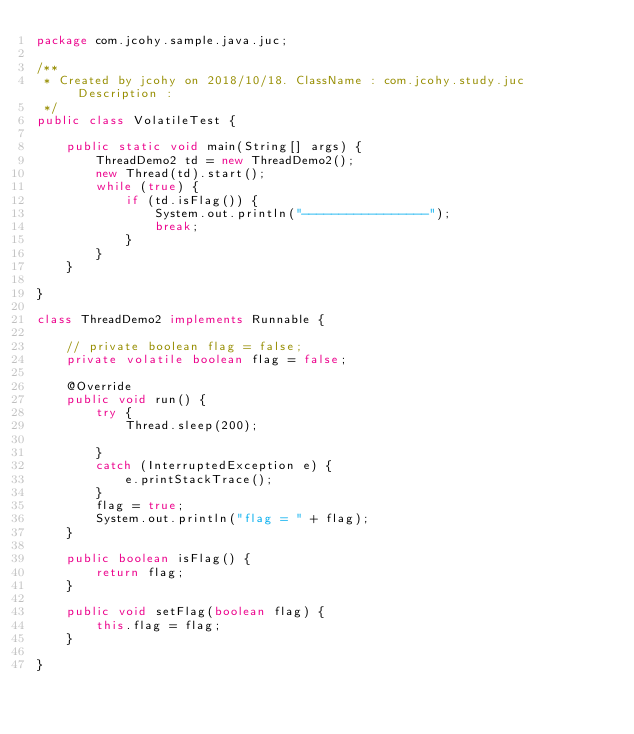<code> <loc_0><loc_0><loc_500><loc_500><_Java_>package com.jcohy.sample.java.juc;

/**
 * Created by jcohy on 2018/10/18. ClassName : com.jcohy.study.juc Description :
 */
public class VolatileTest {

	public static void main(String[] args) {
		ThreadDemo2 td = new ThreadDemo2();
		new Thread(td).start();
		while (true) {
			if (td.isFlag()) {
				System.out.println("-----------------");
				break;
			}
		}
	}

}

class ThreadDemo2 implements Runnable {

	// private boolean flag = false;
	private volatile boolean flag = false;

	@Override
	public void run() {
		try {
			Thread.sleep(200);

		}
		catch (InterruptedException e) {
			e.printStackTrace();
		}
		flag = true;
		System.out.println("flag = " + flag);
	}

	public boolean isFlag() {
		return flag;
	}

	public void setFlag(boolean flag) {
		this.flag = flag;
	}

}</code> 